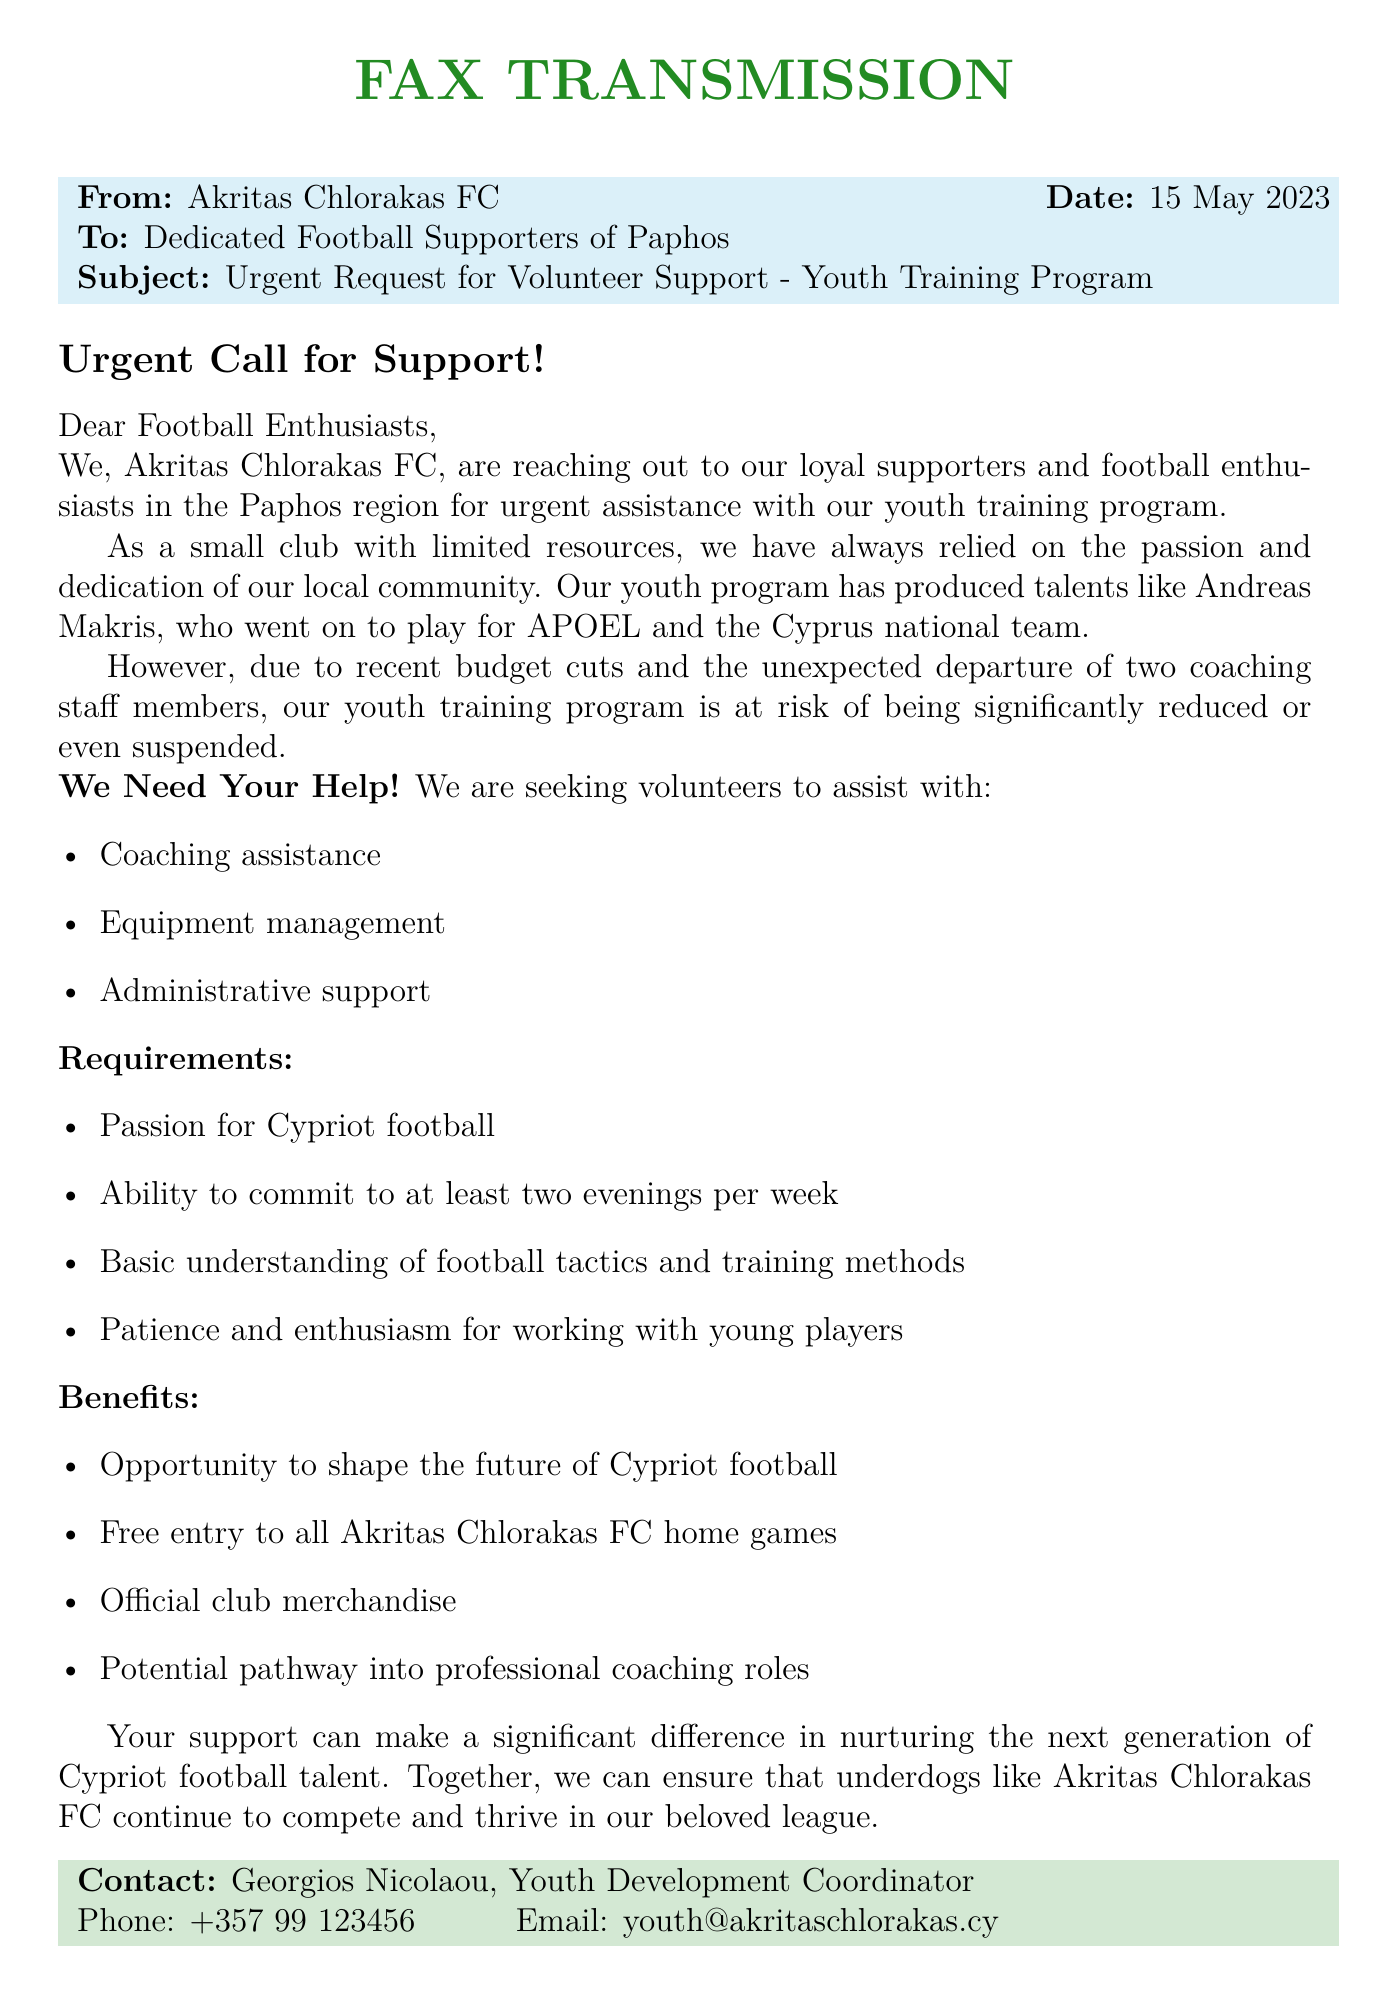What is the name of the football club sending the fax? The fax is from Akritas Chlorakas FC, which is mentioned at the beginning.
Answer: Akritas Chlorakas FC What is the date of the fax? The date of the fax is specified right after the sender information.
Answer: 15 May 2023 Who is the recipient of the fax? The fax is addressed to the Dedicated Football Supporters of Paphos.
Answer: Dedicated Football Supporters of Paphos What did the club request assistance with? The club is seeking volunteer support for their youth training program as stated in the subject line.
Answer: Youth training program What are the two roles of coaching staff that recently departed? It mentions the unexpected departure of two coaching staff members, but does not specify their roles, indicating a general loss.
Answer: Two coaching staff members What is one benefit of volunteering for the club? The document lists several benefits, and one of them includes free entry to all home games.
Answer: Free entry to all home games Who should be contacted for more information? The fax provides a contact name along with phone and email details for inquiries.
Answer: Georgios Nicolaou How many evenings per week should volunteers be able to commit? The requirement clearly states the need for a commitment of at least two evenings per week.
Answer: Two evenings What is a required trait for potential volunteers? The document specifies that volunteers should have a passion for Cypriot football.
Answer: Passion for Cypriot football 